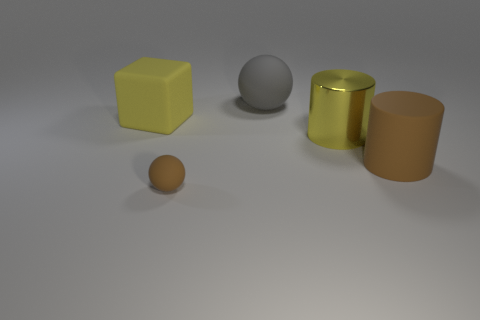What number of other things are the same size as the gray matte object?
Keep it short and to the point. 3. How many tiny brown rubber things are there?
Give a very brief answer. 1. Is there any other thing that is the same shape as the large gray rubber object?
Make the answer very short. Yes. Are the brown object that is behind the tiny brown rubber thing and the yellow thing behind the yellow metal cylinder made of the same material?
Keep it short and to the point. Yes. What material is the yellow block?
Provide a succinct answer. Rubber. How many blocks are the same material as the large brown thing?
Ensure brevity in your answer.  1. What number of metallic objects are yellow objects or big gray objects?
Provide a short and direct response. 1. There is a small thing left of the big yellow metal cylinder; is it the same shape as the gray matte object to the left of the large yellow metal cylinder?
Offer a very short reply. Yes. What is the color of the large matte object that is to the left of the large brown matte cylinder and right of the big yellow matte object?
Make the answer very short. Gray. There is a yellow thing on the left side of the large gray rubber ball; is it the same size as the brown thing that is to the right of the big gray matte sphere?
Offer a very short reply. Yes. 